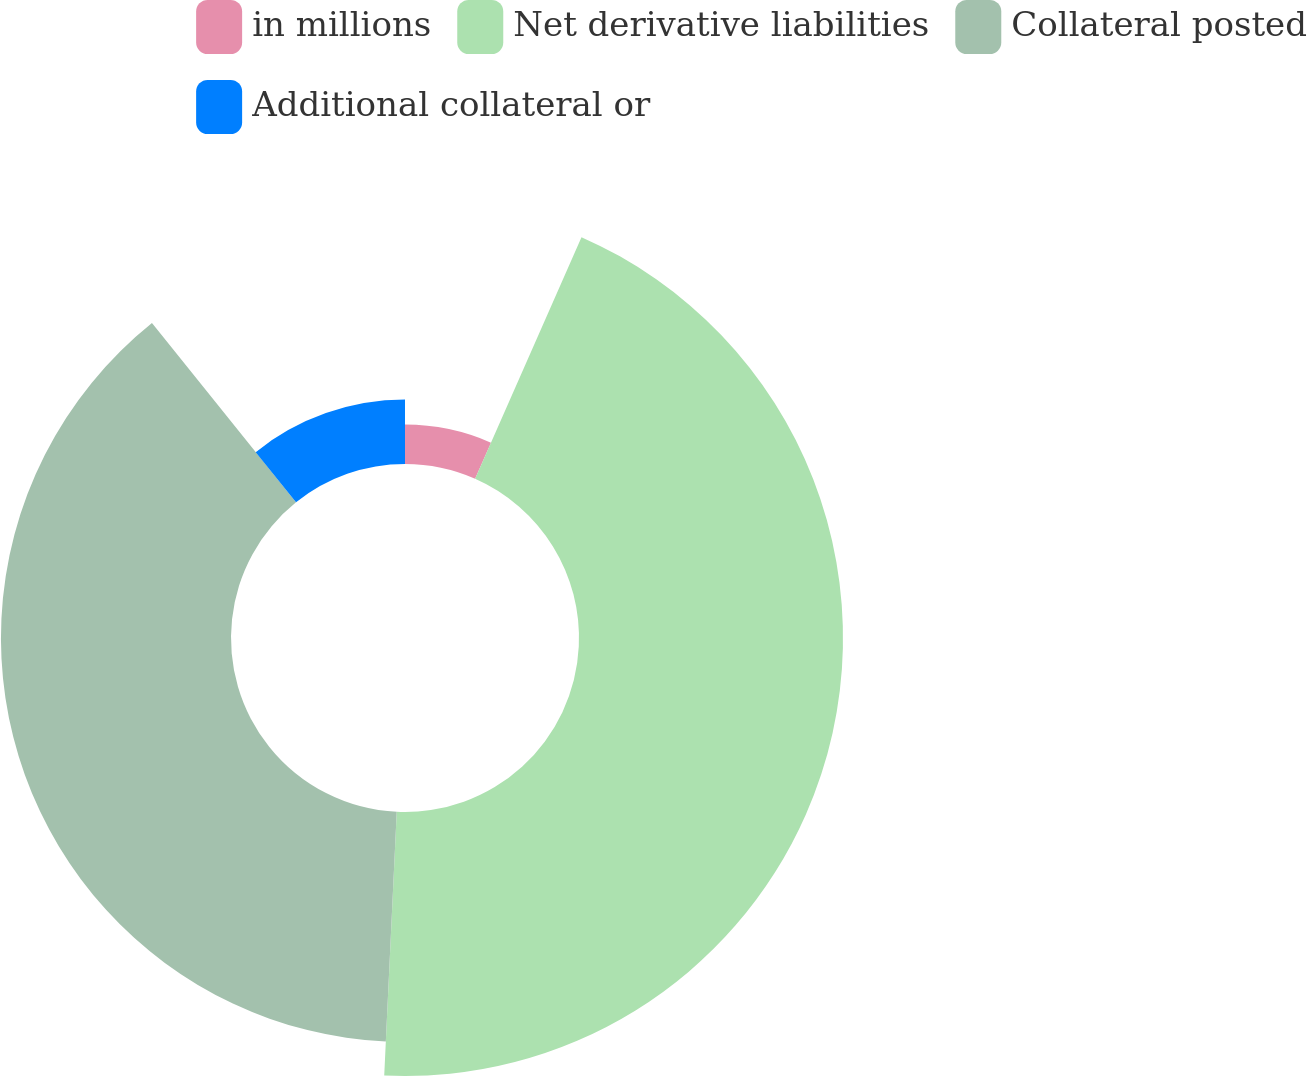Convert chart to OTSL. <chart><loc_0><loc_0><loc_500><loc_500><pie_chart><fcel>in millions<fcel>Net derivative liabilities<fcel>Collateral posted<fcel>Additional collateral or<nl><fcel>6.6%<fcel>44.15%<fcel>38.47%<fcel>10.77%<nl></chart> 